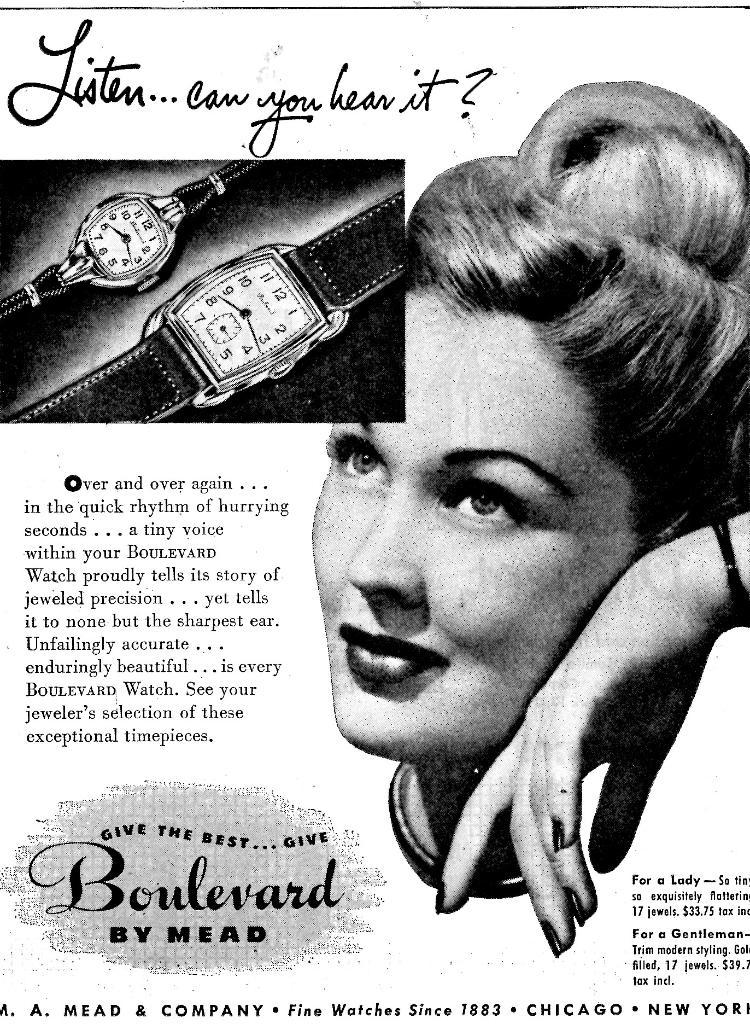First word in the top left?
Your response must be concise. Listen. What is the brand being advertised here?
Offer a very short reply. Boulevard. 